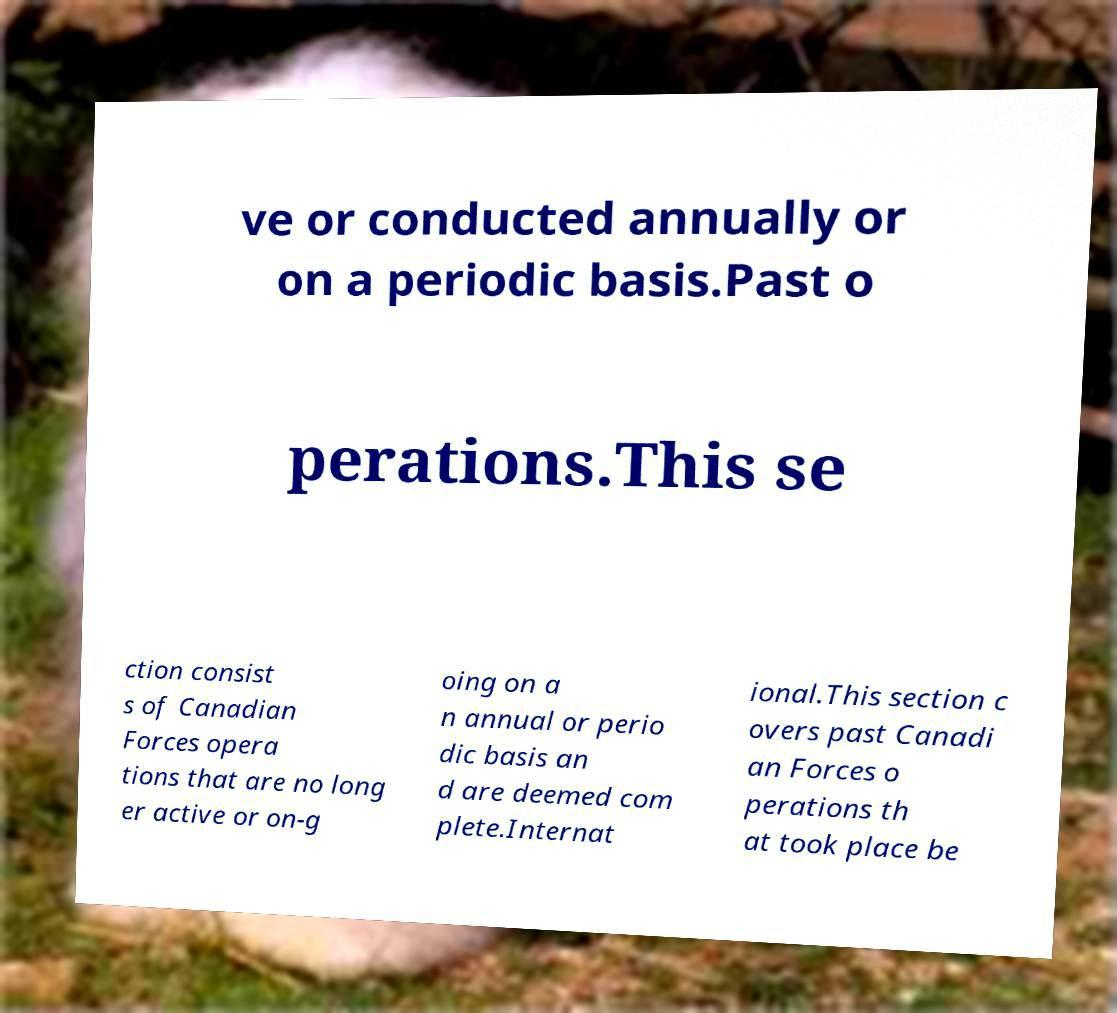For documentation purposes, I need the text within this image transcribed. Could you provide that? ve or conducted annually or on a periodic basis.Past o perations.This se ction consist s of Canadian Forces opera tions that are no long er active or on-g oing on a n annual or perio dic basis an d are deemed com plete.Internat ional.This section c overs past Canadi an Forces o perations th at took place be 